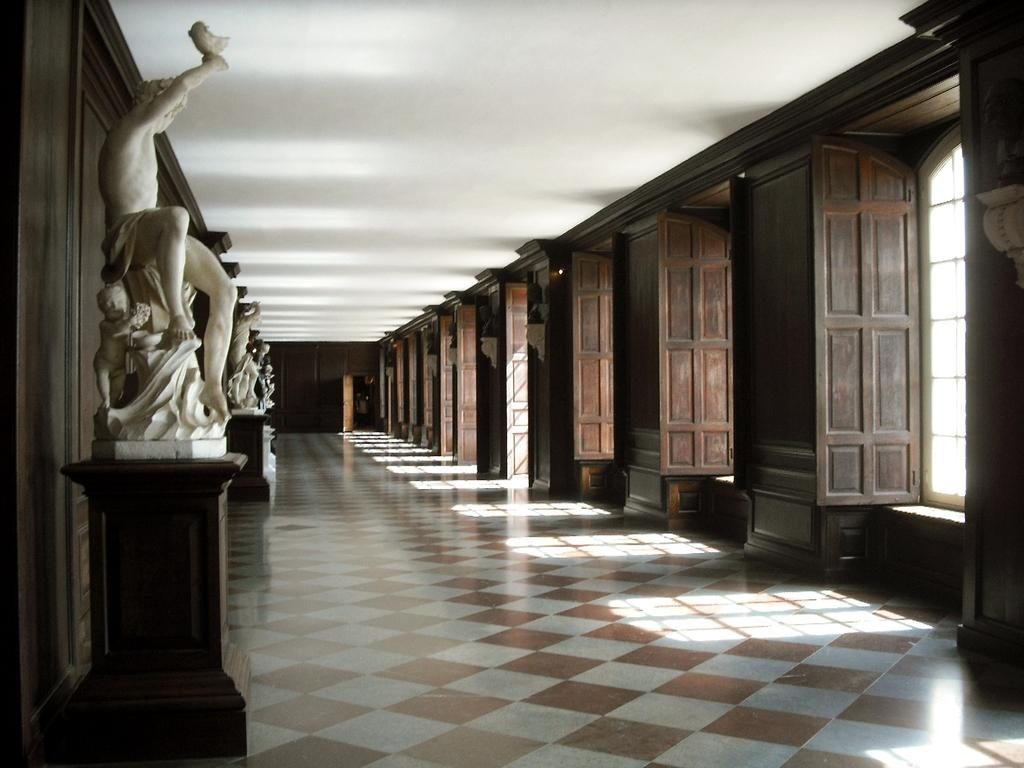What type of building is depicted in the image? There is a hall in the image. What material are the windows made of? The hall has wooden windows. What can be seen on the left side of the image? There are many white marble statues on the left side of the image. What type of jelly can be seen on the floor in the image? There is no jelly present on the floor in the image. What causes the shock in the image? There is no shock depicted in the image. 